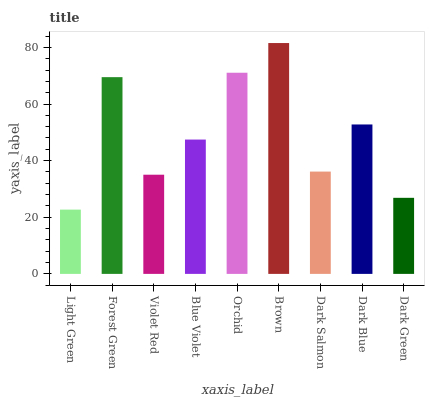Is Light Green the minimum?
Answer yes or no. Yes. Is Brown the maximum?
Answer yes or no. Yes. Is Forest Green the minimum?
Answer yes or no. No. Is Forest Green the maximum?
Answer yes or no. No. Is Forest Green greater than Light Green?
Answer yes or no. Yes. Is Light Green less than Forest Green?
Answer yes or no. Yes. Is Light Green greater than Forest Green?
Answer yes or no. No. Is Forest Green less than Light Green?
Answer yes or no. No. Is Blue Violet the high median?
Answer yes or no. Yes. Is Blue Violet the low median?
Answer yes or no. Yes. Is Violet Red the high median?
Answer yes or no. No. Is Brown the low median?
Answer yes or no. No. 